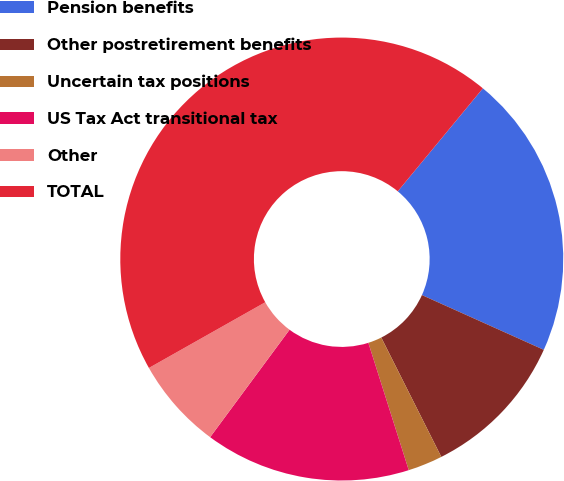Convert chart to OTSL. <chart><loc_0><loc_0><loc_500><loc_500><pie_chart><fcel>Pension benefits<fcel>Other postretirement benefits<fcel>Uncertain tax positions<fcel>US Tax Act transitional tax<fcel>Other<fcel>TOTAL<nl><fcel>20.73%<fcel>10.86%<fcel>2.53%<fcel>15.02%<fcel>6.69%<fcel>44.18%<nl></chart> 